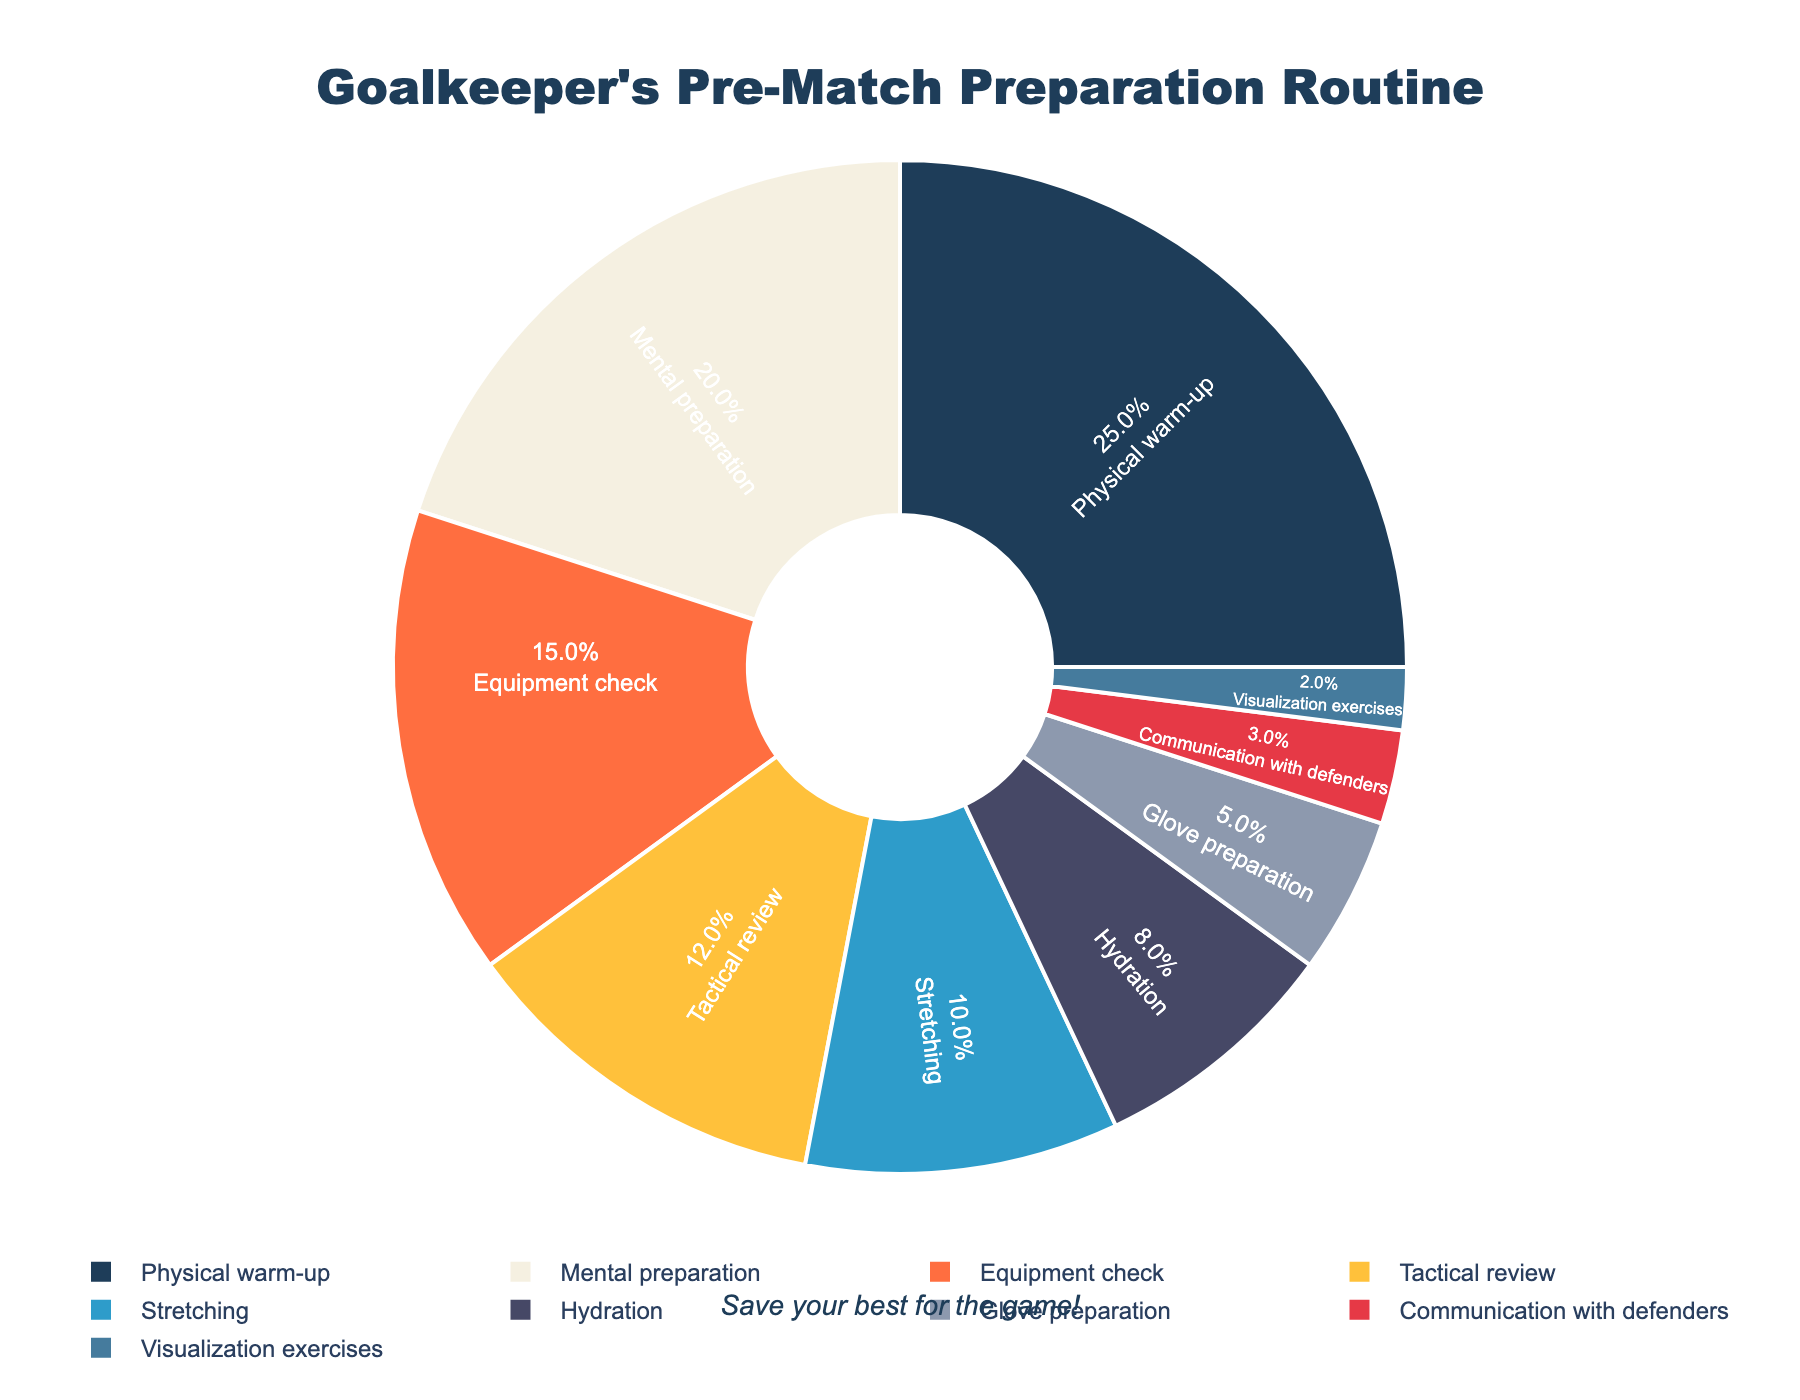What is the largest component of the goalkeeper's pre-match preparation routine? The largest component can be identified by the highest percentage in the pie chart. Physical warm-up occupies 25%, the largest in the chart.
Answer: Physical warm-up Which preparation activity is twice as important as glove preparation? Looking at the pie chart, glove preparation is 5%. To find an activity twice this amount, we search for an activity that is 10%, which is stretching.
Answer: Stretching Combine the percentages for hydration and glove preparation. Do they make up more or less than the tactical review? Hydration and glove preparation are 8% + 5% = 13%. The tactical review is 12%. Comparing the totals, 13% is more than 12%.
Answer: More Which three categories together form more than half of the preparation routine? We look for the three highest percentages and sum them: Physical warm-up (25%), Mental preparation (20%), and Equipment check (15%). Together, they form 25% + 20% + 15% = 60%.
Answer: Physical warm-up, Mental preparation, Equipment check What is the combined percentage for all activities classified as equipment-related (Equipment check and Glove preparation)? Adding up Equipment check (15%) and Glove preparation (5%) gives 15% + 5% = 20%.
Answer: 20% Which activity is highlighted using an orange color in the chart? By identifying the visual representation of colors in the pie chart, Tactical review is highlighted in orange.
Answer: Tactical review How much more time is spent on mental preparation compared to communication with defenders? Mental preparation is 20% and communication with defenders is 3%; therefore, 20% - 3% = 17%.
Answer: 17% Which three activities together constitute the smallest portion of the preparation routine? Reviewing the smallest percentages, Visualization exercises (2%), Communication with defenders (3%), and Glove preparation (5%) add up to 2% + 3% + 5% = 10%.
Answer: Visualization exercises, Communication with defenders, Glove preparation Is the percentage of time spent stretching more, less, or the same as the time spent on tactical review plus visualization exercises? Stretching is 10%. Tactical review (12%) plus visualization exercises (2%) equals 14%. Comparing the totals, 10% is less than 14%.
Answer: Less 